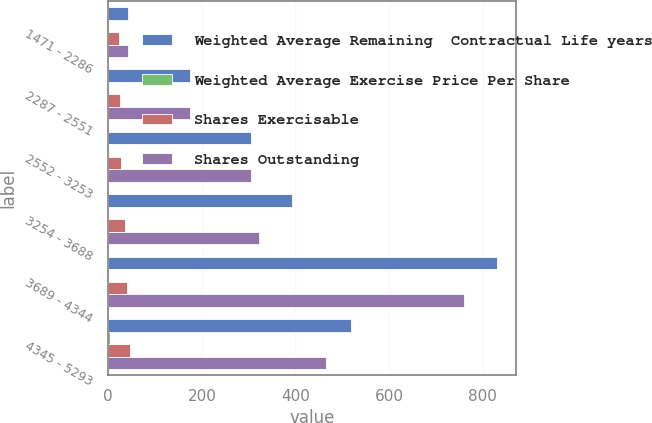Convert chart. <chart><loc_0><loc_0><loc_500><loc_500><stacked_bar_chart><ecel><fcel>1471 - 2286<fcel>2287 - 2551<fcel>2552 - 3253<fcel>3254 - 3688<fcel>3689 - 4344<fcel>4345 - 5293<nl><fcel>Weighted Average Remaining  Contractual Life years<fcel>43.27<fcel>174<fcel>304<fcel>392<fcel>830<fcel>518<nl><fcel>Weighted Average Exercise Price Per Share<fcel>1.43<fcel>1.5<fcel>0.9<fcel>2.32<fcel>2.55<fcel>3.5<nl><fcel>Shares Exercisable<fcel>22.45<fcel>25.44<fcel>27.41<fcel>35.89<fcel>39.49<fcel>47.05<nl><fcel>Shares Outstanding<fcel>43.27<fcel>174<fcel>304<fcel>323<fcel>760<fcel>465<nl></chart> 